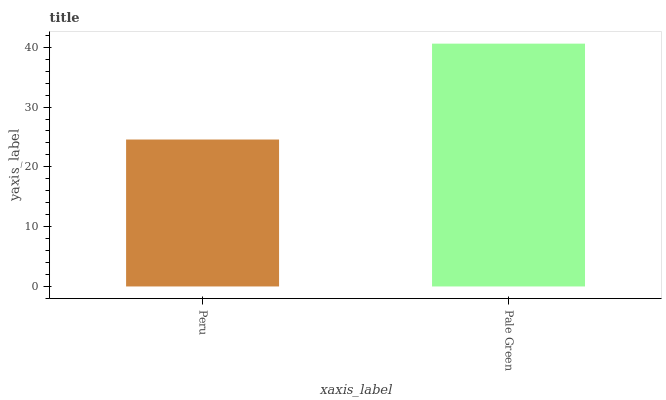Is Pale Green the minimum?
Answer yes or no. No. Is Pale Green greater than Peru?
Answer yes or no. Yes. Is Peru less than Pale Green?
Answer yes or no. Yes. Is Peru greater than Pale Green?
Answer yes or no. No. Is Pale Green less than Peru?
Answer yes or no. No. Is Pale Green the high median?
Answer yes or no. Yes. Is Peru the low median?
Answer yes or no. Yes. Is Peru the high median?
Answer yes or no. No. Is Pale Green the low median?
Answer yes or no. No. 